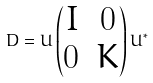Convert formula to latex. <formula><loc_0><loc_0><loc_500><loc_500>D = U \begin{pmatrix} I & 0 \\ 0 & K \end{pmatrix} U ^ { * }</formula> 